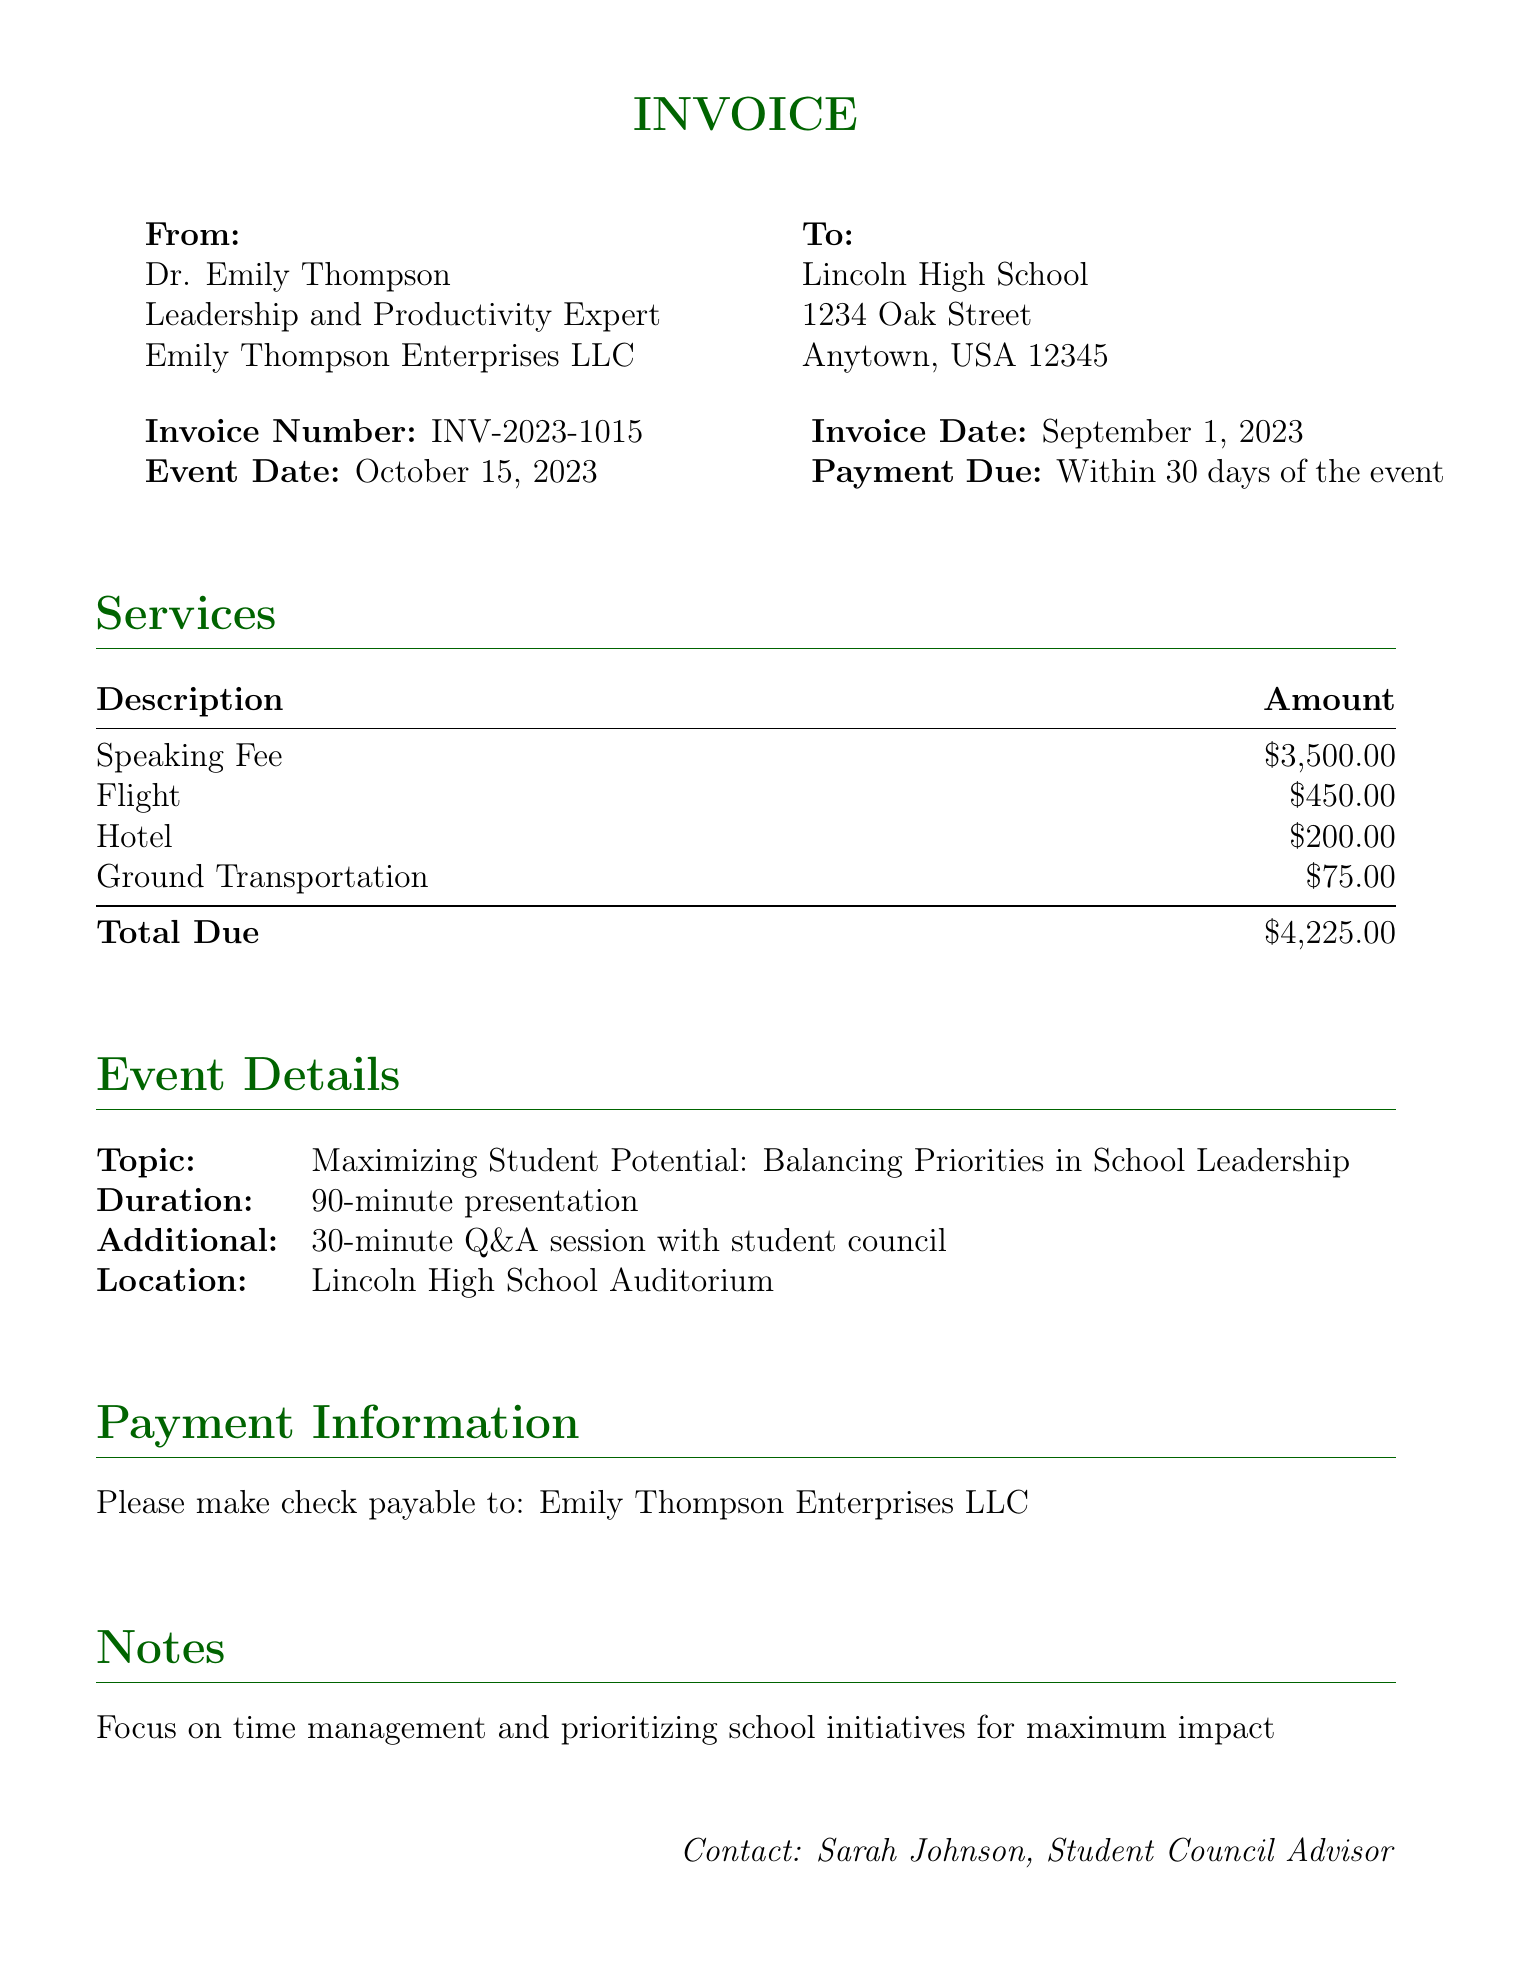What is the speaking fee? The speaking fee is clearly listed in the services section of the document as $3,500.00.
Answer: $3,500.00 Who is the speaker? The document specifies the speaker's name as Dr. Emily Thompson.
Answer: Dr. Emily Thompson What is the total amount due? The total amount due is calculated in the services section summing all items, which is $4,225.00.
Answer: $4,225.00 When is the payment due? The payment due date is mentioned in the invoice timeline, stating it is within 30 days of the event.
Answer: Within 30 days of the event What is the topic of the presentation? The topic for the event is provided in the event details as "Maximizing Student Potential: Balancing Priorities in School Leadership."
Answer: Maximizing Student Potential: Balancing Priorities in School Leadership How long is the presentation? The duration of the presentation is noted as 90 minutes in the event details section.
Answer: 90-minute presentation What are the ground transportation expenses? The expenses for ground transportation are listed specifically in the services section as $75.00.
Answer: $75.00 Who should checks be made payable to? The payment information section clearly states that checks should be made payable to Emily Thompson Enterprises LLC.
Answer: Emily Thompson Enterprises LLC 